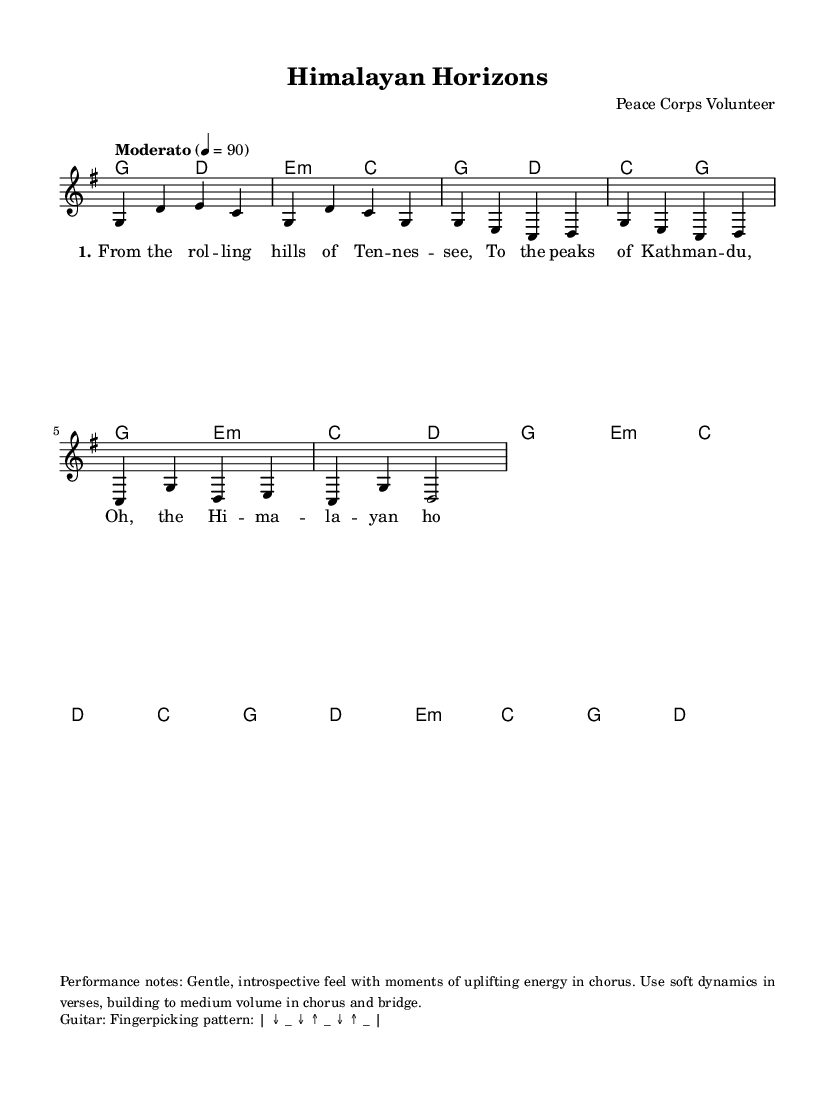What is the key signature of this music? The key signature is G major, which includes one sharp (F#). You can determine this by looking at the opening of the score where the key signature is indicated.
Answer: G major What is the time signature of this piece? The time signature is 4/4, which means there are four beats in a measure, and the quarter note receives one beat. This can be observed at the beginning of the score.
Answer: 4/4 What is the tempo marking for this music? The tempo marking is "Moderato" with a tempo of 90 beats per minute. This is indicated near the beginning of the score, specifying the desired speed of the performance.
Answer: Moderato How many measures are in the chorus section? The chorus section of the music consists of 4 measures. This can be determined by counting the measures notated in the chord and melody parts marked "Chorus."
Answer: 4 What is the primary mood suggested by the performance notes? The primary mood suggested is gentle and introspective, which can be gleaned from the performance notes that describe the dynamics and feel of the piece.
Answer: Gentle, introspective What geographic locations are mentioned in the first verse? The first verse mentions Tennessee and Kathmandu. This is identified by reading the lyrical content provided in the lyrics section of the score.
Answer: Tennessee and Kathmandu 